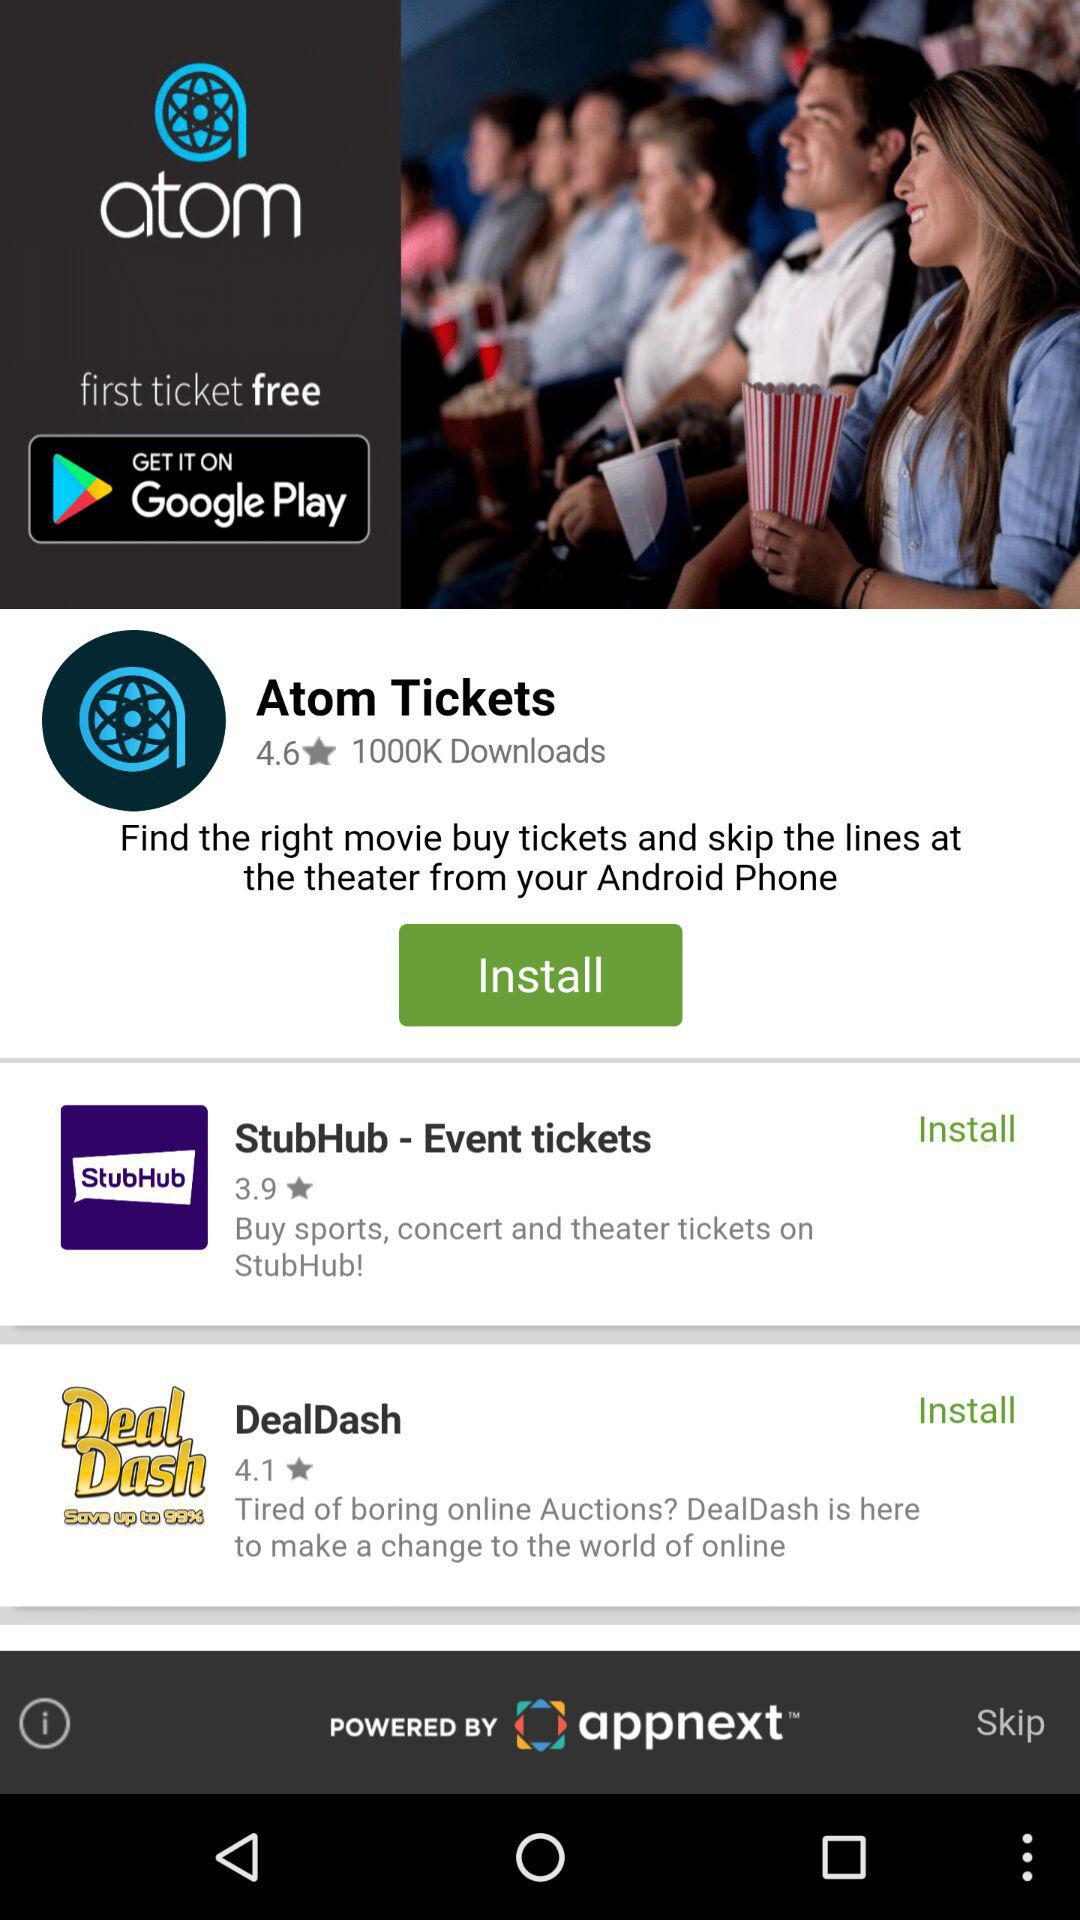What is the rating for "DealDash"? The rating is 4.1 stars. 